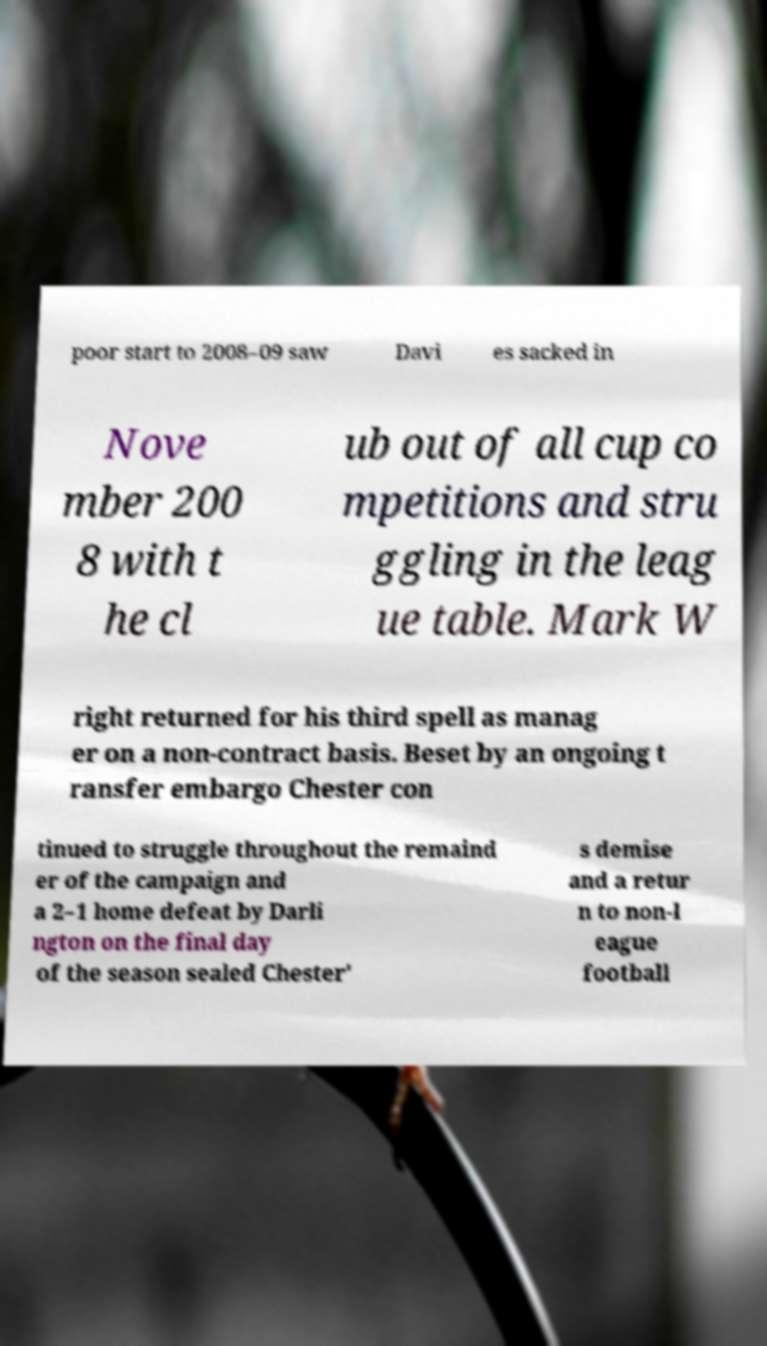Can you accurately transcribe the text from the provided image for me? poor start to 2008–09 saw Davi es sacked in Nove mber 200 8 with t he cl ub out of all cup co mpetitions and stru ggling in the leag ue table. Mark W right returned for his third spell as manag er on a non-contract basis. Beset by an ongoing t ransfer embargo Chester con tinued to struggle throughout the remaind er of the campaign and a 2–1 home defeat by Darli ngton on the final day of the season sealed Chester' s demise and a retur n to non-l eague football 